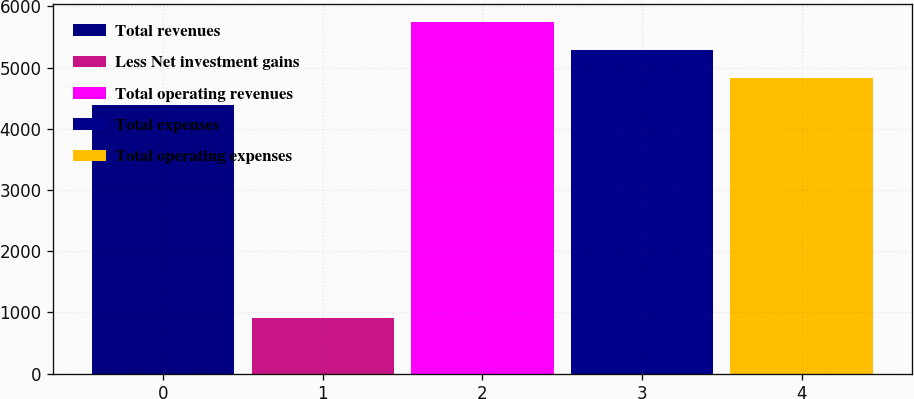Convert chart. <chart><loc_0><loc_0><loc_500><loc_500><bar_chart><fcel>Total revenues<fcel>Less Net investment gains<fcel>Total operating revenues<fcel>Total expenses<fcel>Total operating expenses<nl><fcel>4383<fcel>903<fcel>5748.6<fcel>5293.4<fcel>4838.2<nl></chart> 